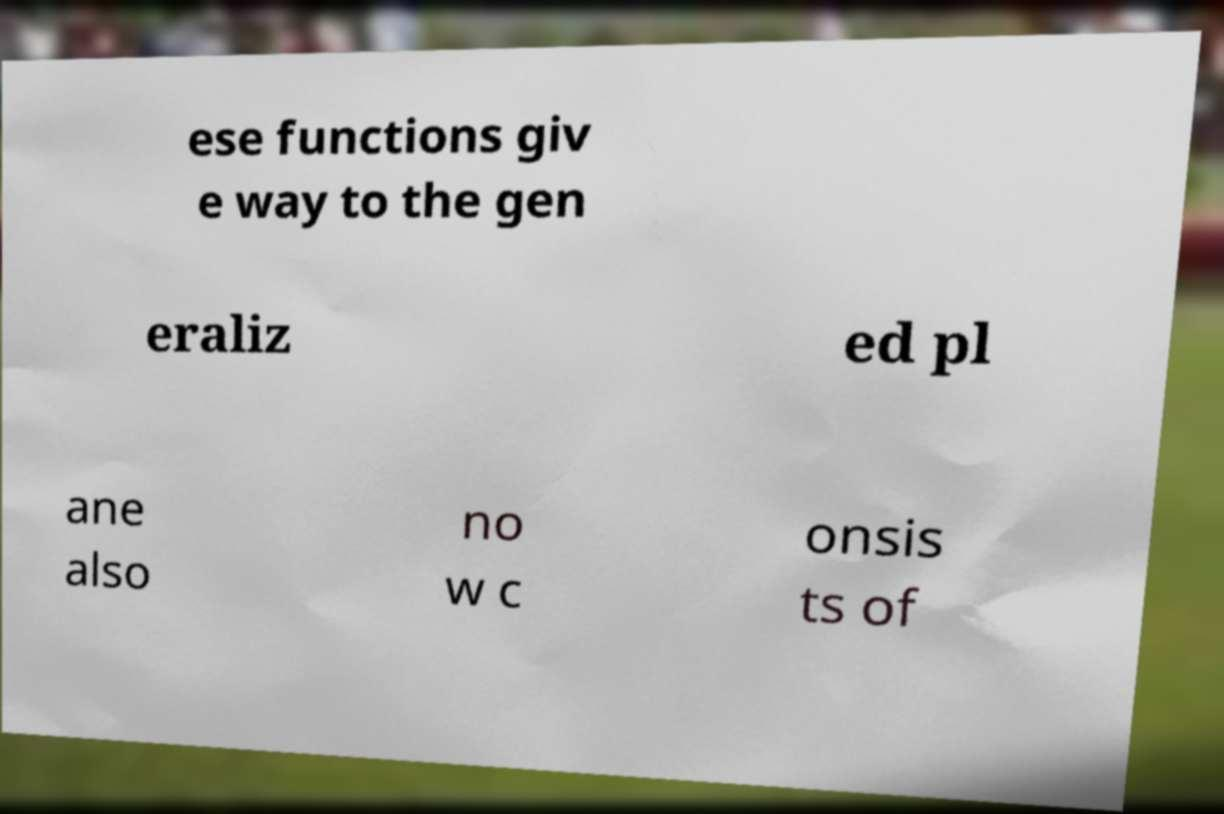Can you read and provide the text displayed in the image?This photo seems to have some interesting text. Can you extract and type it out for me? ese functions giv e way to the gen eraliz ed pl ane also no w c onsis ts of 